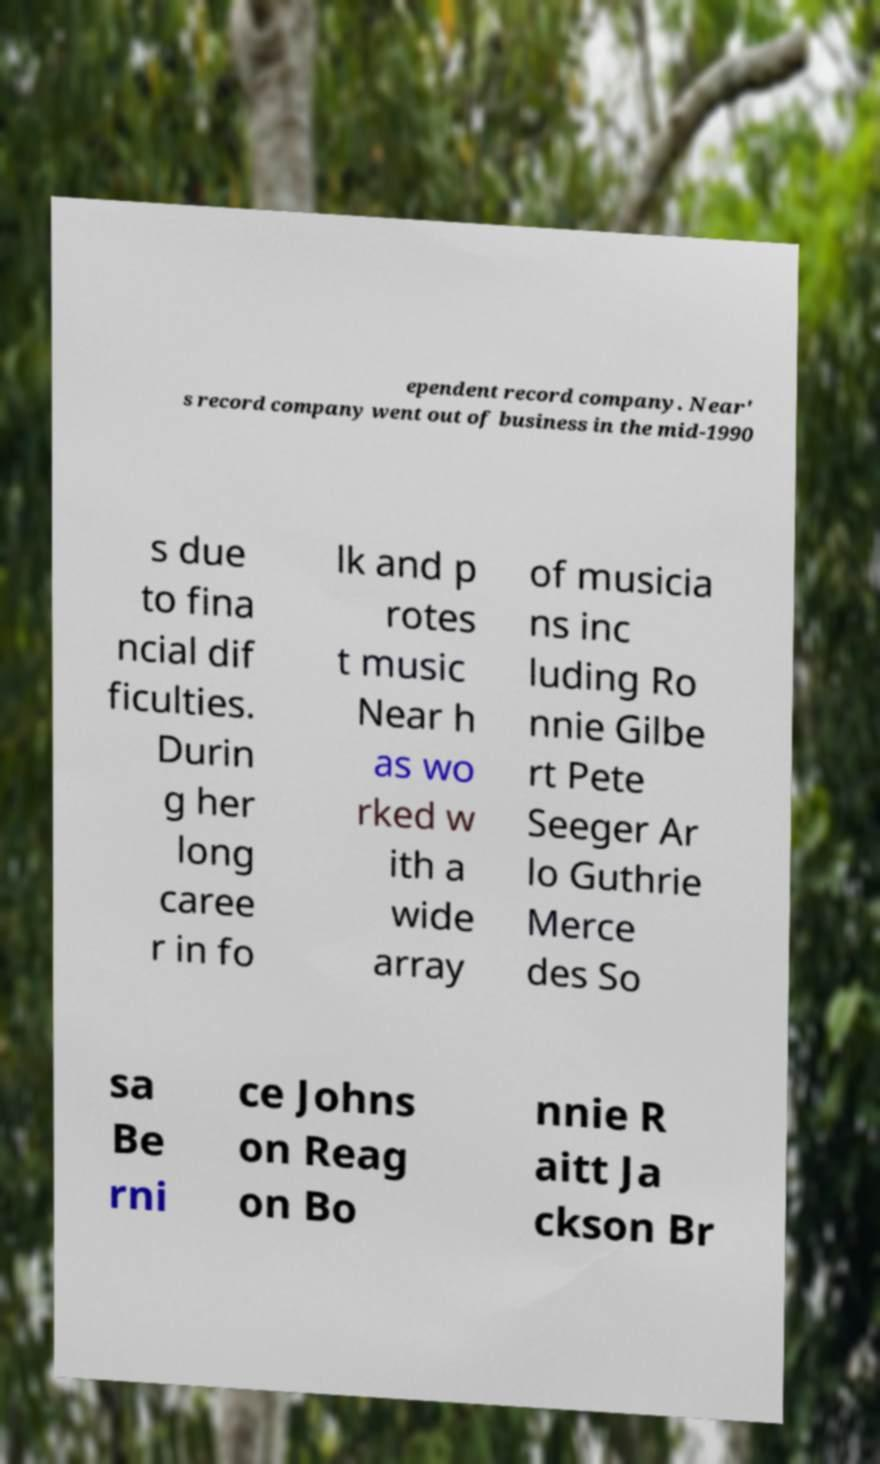I need the written content from this picture converted into text. Can you do that? ependent record company. Near' s record company went out of business in the mid-1990 s due to fina ncial dif ficulties. Durin g her long caree r in fo lk and p rotes t music Near h as wo rked w ith a wide array of musicia ns inc luding Ro nnie Gilbe rt Pete Seeger Ar lo Guthrie Merce des So sa Be rni ce Johns on Reag on Bo nnie R aitt Ja ckson Br 